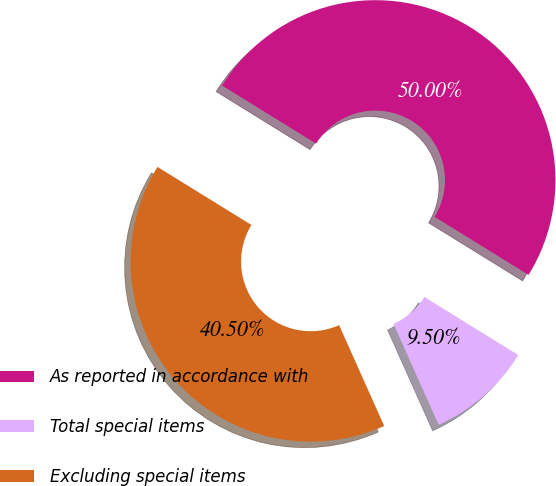<chart> <loc_0><loc_0><loc_500><loc_500><pie_chart><fcel>As reported in accordance with<fcel>Total special items<fcel>Excluding special items<nl><fcel>50.0%<fcel>9.5%<fcel>40.5%<nl></chart> 